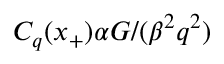Convert formula to latex. <formula><loc_0><loc_0><loc_500><loc_500>C _ { q } ( x _ { + } ) \alpha G / ( \beta ^ { 2 } q ^ { 2 } )</formula> 